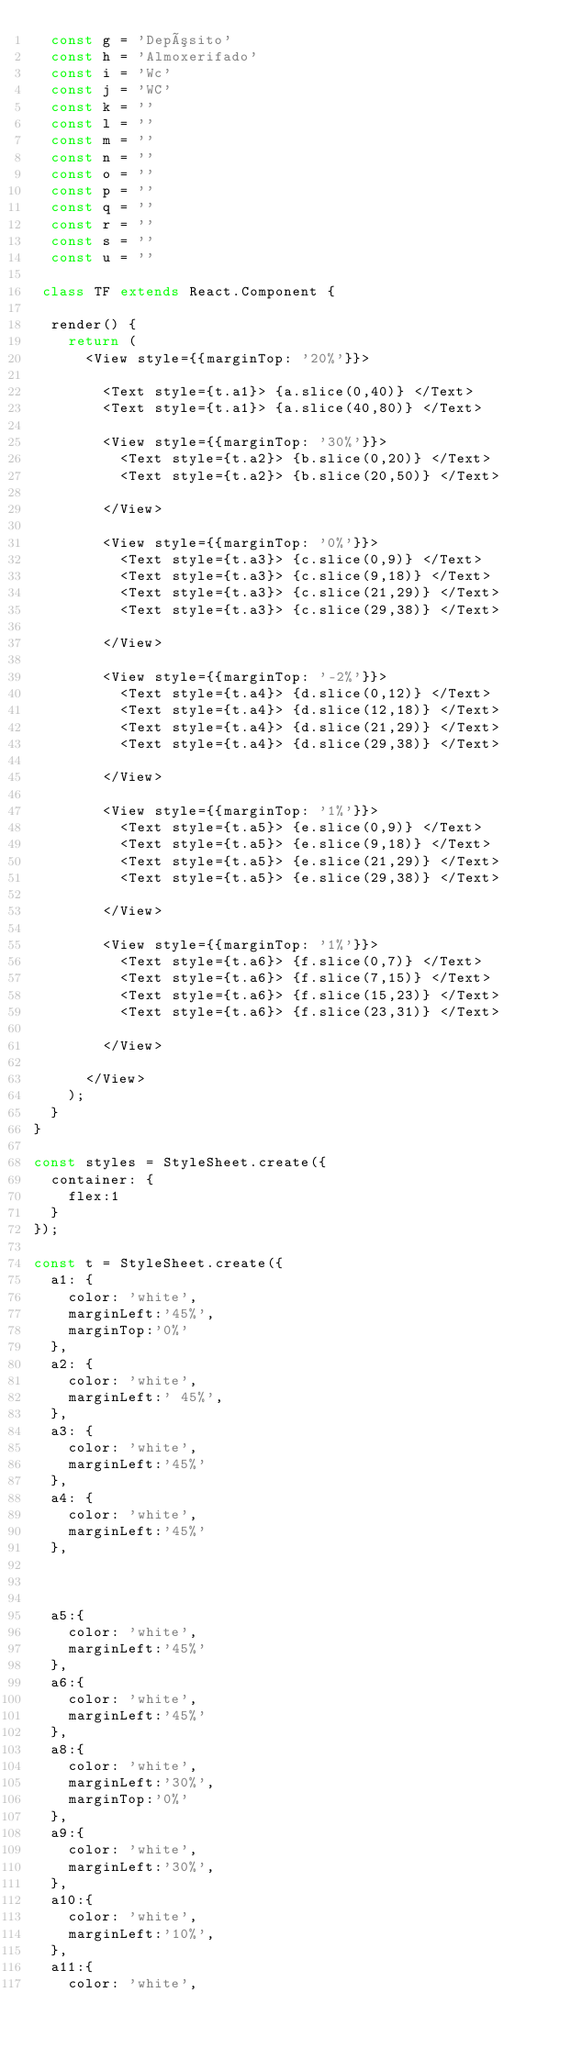Convert code to text. <code><loc_0><loc_0><loc_500><loc_500><_JavaScript_>  const g = 'Depósito'
  const h = 'Almoxerifado'
  const i = 'Wc'
  const j = 'WC'
  const k = ''
  const l = ''
  const m = ''
  const n = ''
  const o = ''
  const p = ''
  const q = ''
  const r = ''
  const s = ''
  const u = ''

 class TF extends React.Component {

  render() {
    return (
      <View style={{marginTop: '20%'}}>

        <Text style={t.a1}> {a.slice(0,40)} </Text>
        <Text style={t.a1}> {a.slice(40,80)} </Text>

        <View style={{marginTop: '30%'}}>
          <Text style={t.a2}> {b.slice(0,20)} </Text>
          <Text style={t.a2}> {b.slice(20,50)} </Text>

        </View>

        <View style={{marginTop: '0%'}}>
          <Text style={t.a3}> {c.slice(0,9)} </Text>
          <Text style={t.a3}> {c.slice(9,18)} </Text>
          <Text style={t.a3}> {c.slice(21,29)} </Text>
          <Text style={t.a3}> {c.slice(29,38)} </Text>

        </View>

        <View style={{marginTop: '-2%'}}>
          <Text style={t.a4}> {d.slice(0,12)} </Text>
          <Text style={t.a4}> {d.slice(12,18)} </Text>
          <Text style={t.a4}> {d.slice(21,29)} </Text>
          <Text style={t.a4}> {d.slice(29,38)} </Text>

        </View>

        <View style={{marginTop: '1%'}}>
          <Text style={t.a5}> {e.slice(0,9)} </Text>
          <Text style={t.a5}> {e.slice(9,18)} </Text>
          <Text style={t.a5}> {e.slice(21,29)} </Text>
          <Text style={t.a5}> {e.slice(29,38)} </Text>

        </View>

        <View style={{marginTop: '1%'}}>
          <Text style={t.a6}> {f.slice(0,7)} </Text>
          <Text style={t.a6}> {f.slice(7,15)} </Text>
          <Text style={t.a6}> {f.slice(15,23)} </Text>
          <Text style={t.a6}> {f.slice(23,31)} </Text>

        </View>

      </View>
    );
  }
}

const styles = StyleSheet.create({
  container: {
    flex:1
  }
});

const t = StyleSheet.create({
  a1: {
    color: 'white',
    marginLeft:'45%',
    marginTop:'0%'
  },
  a2: {
    color: 'white',
    marginLeft:' 45%',
  },
  a3: {
    color: 'white',
    marginLeft:'45%'
  },
  a4: {
    color: 'white',
    marginLeft:'45%'
  },



  a5:{
    color: 'white',
    marginLeft:'45%'
  },
  a6:{
    color: 'white',
    marginLeft:'45%'
  },
  a8:{
    color: 'white',
    marginLeft:'30%',
    marginTop:'0%'
  },
  a9:{
    color: 'white',
    marginLeft:'30%',
  },
  a10:{
    color: 'white',
    marginLeft:'10%',
  },
  a11:{
    color: 'white',</code> 